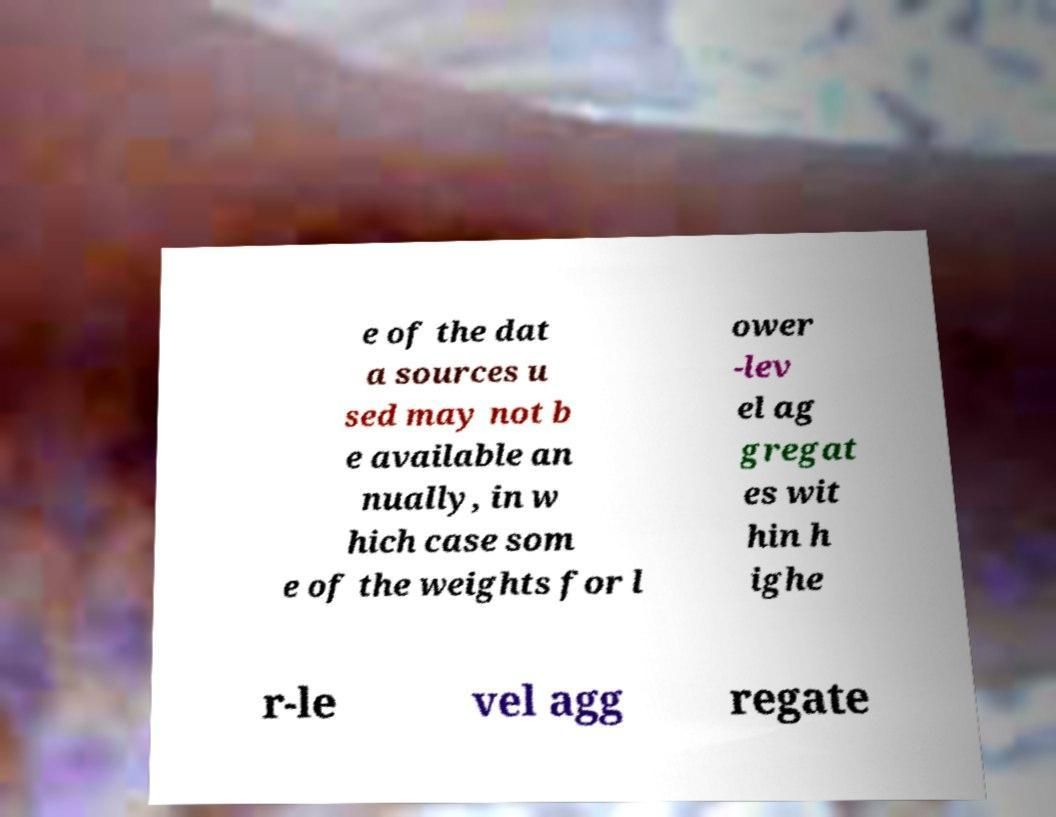Please read and relay the text visible in this image. What does it say? e of the dat a sources u sed may not b e available an nually, in w hich case som e of the weights for l ower -lev el ag gregat es wit hin h ighe r-le vel agg regate 